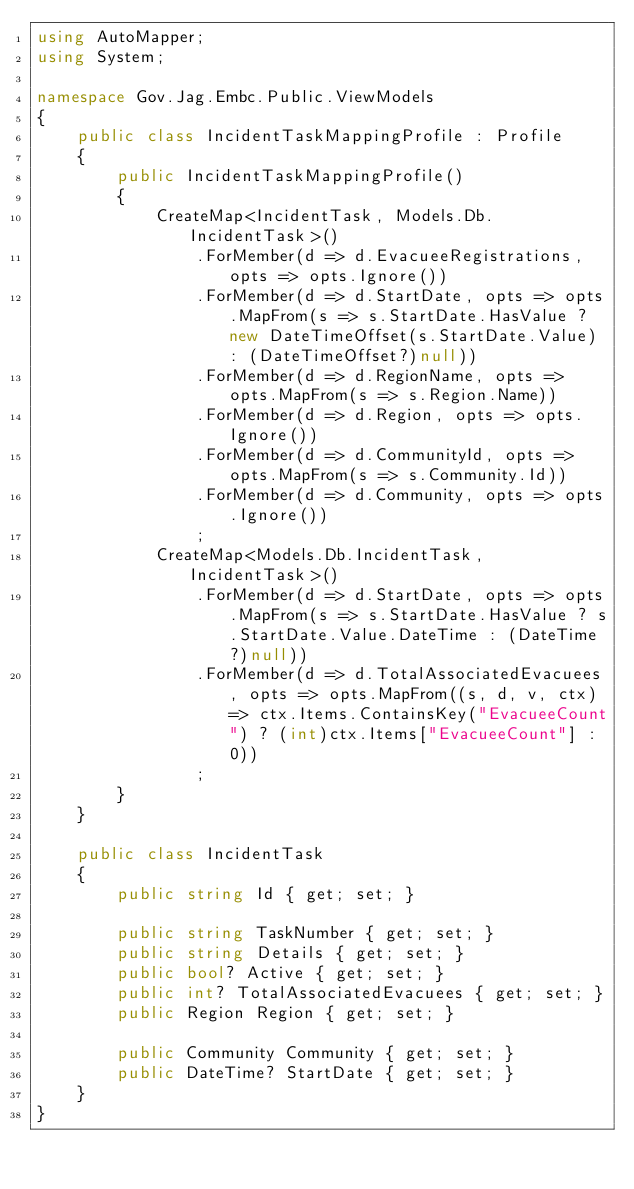<code> <loc_0><loc_0><loc_500><loc_500><_C#_>using AutoMapper;
using System;

namespace Gov.Jag.Embc.Public.ViewModels
{
    public class IncidentTaskMappingProfile : Profile
    {
        public IncidentTaskMappingProfile()
        {
            CreateMap<IncidentTask, Models.Db.IncidentTask>()
                .ForMember(d => d.EvacueeRegistrations, opts => opts.Ignore())
                .ForMember(d => d.StartDate, opts => opts.MapFrom(s => s.StartDate.HasValue ? new DateTimeOffset(s.StartDate.Value) : (DateTimeOffset?)null))
                .ForMember(d => d.RegionName, opts => opts.MapFrom(s => s.Region.Name))
                .ForMember(d => d.Region, opts => opts.Ignore())
                .ForMember(d => d.CommunityId, opts => opts.MapFrom(s => s.Community.Id))
                .ForMember(d => d.Community, opts => opts.Ignore())
                ;
            CreateMap<Models.Db.IncidentTask, IncidentTask>()
                .ForMember(d => d.StartDate, opts => opts.MapFrom(s => s.StartDate.HasValue ? s.StartDate.Value.DateTime : (DateTime?)null))
                .ForMember(d => d.TotalAssociatedEvacuees, opts => opts.MapFrom((s, d, v, ctx) => ctx.Items.ContainsKey("EvacueeCount") ? (int)ctx.Items["EvacueeCount"] : 0))
                ;
        }
    }

    public class IncidentTask
    {
        public string Id { get; set; }

        public string TaskNumber { get; set; }
        public string Details { get; set; }
        public bool? Active { get; set; }
        public int? TotalAssociatedEvacuees { get; set; }
        public Region Region { get; set; }

        public Community Community { get; set; }
        public DateTime? StartDate { get; set; }
    }
}
</code> 